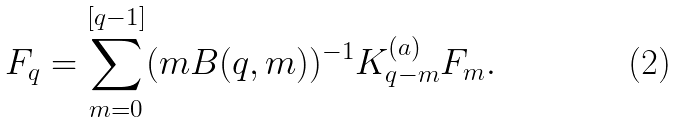<formula> <loc_0><loc_0><loc_500><loc_500>F _ { q } = \sum _ { m = 0 } ^ { [ q - 1 ] } ( m B ( q , m ) ) ^ { - 1 } K _ { q - m } ^ { ( a ) } F _ { m } .</formula> 